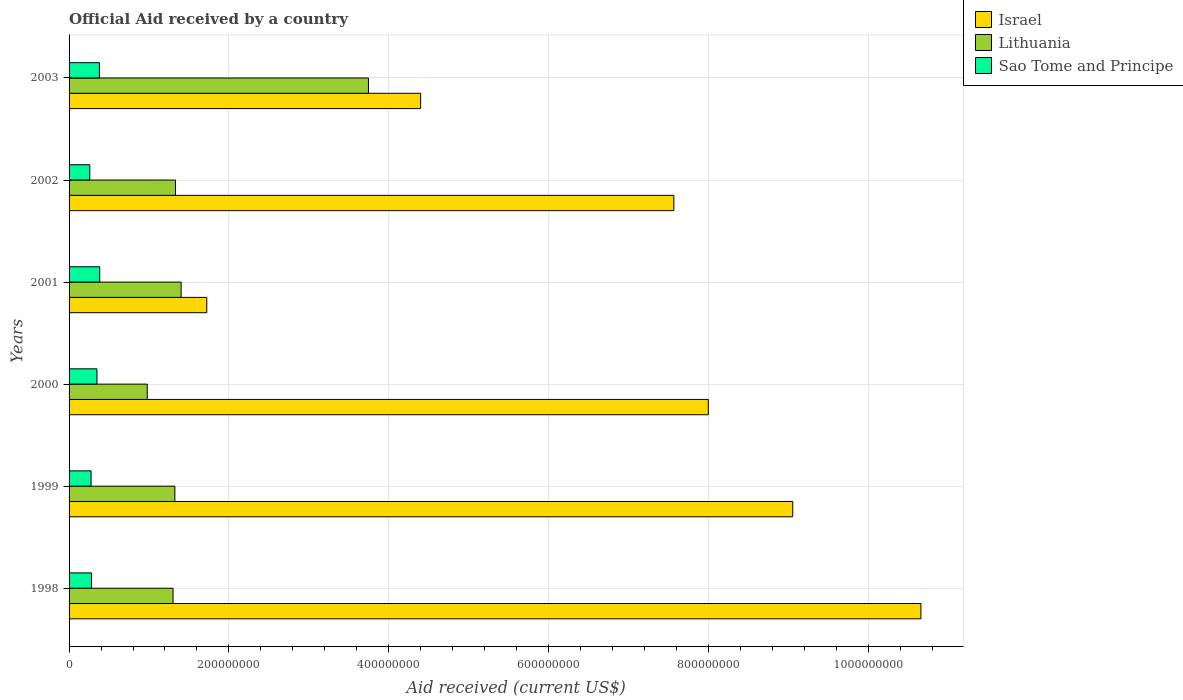How many bars are there on the 1st tick from the top?
Ensure brevity in your answer.  3. What is the net official aid received in Lithuania in 2002?
Your response must be concise. 1.33e+08. Across all years, what is the maximum net official aid received in Israel?
Your answer should be compact. 1.07e+09. Across all years, what is the minimum net official aid received in Sao Tome and Principe?
Ensure brevity in your answer.  2.59e+07. In which year was the net official aid received in Sao Tome and Principe maximum?
Provide a short and direct response. 2001. What is the total net official aid received in Israel in the graph?
Offer a terse response. 4.14e+09. What is the difference between the net official aid received in Lithuania in 1998 and that in 2002?
Offer a terse response. -3.08e+06. What is the difference between the net official aid received in Sao Tome and Principe in 2000 and the net official aid received in Israel in 2002?
Provide a succinct answer. -7.22e+08. What is the average net official aid received in Israel per year?
Ensure brevity in your answer.  6.90e+08. In the year 2000, what is the difference between the net official aid received in Lithuania and net official aid received in Israel?
Offer a terse response. -7.02e+08. In how many years, is the net official aid received in Israel greater than 360000000 US$?
Make the answer very short. 5. What is the ratio of the net official aid received in Sao Tome and Principe in 1998 to that in 2001?
Ensure brevity in your answer.  0.73. Is the net official aid received in Lithuania in 1999 less than that in 2001?
Provide a succinct answer. Yes. Is the difference between the net official aid received in Lithuania in 1999 and 2000 greater than the difference between the net official aid received in Israel in 1999 and 2000?
Offer a very short reply. No. What is the difference between the highest and the lowest net official aid received in Lithuania?
Your answer should be compact. 2.77e+08. In how many years, is the net official aid received in Lithuania greater than the average net official aid received in Lithuania taken over all years?
Provide a succinct answer. 1. What does the 2nd bar from the bottom in 2001 represents?
Keep it short and to the point. Lithuania. Is it the case that in every year, the sum of the net official aid received in Israel and net official aid received in Lithuania is greater than the net official aid received in Sao Tome and Principe?
Offer a very short reply. Yes. Are all the bars in the graph horizontal?
Offer a terse response. Yes. What is the difference between two consecutive major ticks on the X-axis?
Provide a succinct answer. 2.00e+08. Does the graph contain grids?
Your response must be concise. Yes. How many legend labels are there?
Give a very brief answer. 3. How are the legend labels stacked?
Provide a succinct answer. Vertical. What is the title of the graph?
Make the answer very short. Official Aid received by a country. What is the label or title of the X-axis?
Provide a short and direct response. Aid received (current US$). What is the Aid received (current US$) of Israel in 1998?
Ensure brevity in your answer.  1.07e+09. What is the Aid received (current US$) of Lithuania in 1998?
Offer a very short reply. 1.30e+08. What is the Aid received (current US$) in Sao Tome and Principe in 1998?
Give a very brief answer. 2.81e+07. What is the Aid received (current US$) of Israel in 1999?
Your response must be concise. 9.06e+08. What is the Aid received (current US$) of Lithuania in 1999?
Your response must be concise. 1.32e+08. What is the Aid received (current US$) of Sao Tome and Principe in 1999?
Ensure brevity in your answer.  2.75e+07. What is the Aid received (current US$) of Israel in 2000?
Offer a very short reply. 8.00e+08. What is the Aid received (current US$) of Lithuania in 2000?
Provide a succinct answer. 9.78e+07. What is the Aid received (current US$) in Sao Tome and Principe in 2000?
Offer a terse response. 3.49e+07. What is the Aid received (current US$) of Israel in 2001?
Provide a short and direct response. 1.72e+08. What is the Aid received (current US$) in Lithuania in 2001?
Your response must be concise. 1.40e+08. What is the Aid received (current US$) in Sao Tome and Principe in 2001?
Ensure brevity in your answer.  3.84e+07. What is the Aid received (current US$) of Israel in 2002?
Provide a succinct answer. 7.57e+08. What is the Aid received (current US$) of Lithuania in 2002?
Offer a terse response. 1.33e+08. What is the Aid received (current US$) in Sao Tome and Principe in 2002?
Ensure brevity in your answer.  2.59e+07. What is the Aid received (current US$) of Israel in 2003?
Provide a succinct answer. 4.40e+08. What is the Aid received (current US$) of Lithuania in 2003?
Provide a short and direct response. 3.75e+08. What is the Aid received (current US$) of Sao Tome and Principe in 2003?
Ensure brevity in your answer.  3.80e+07. Across all years, what is the maximum Aid received (current US$) of Israel?
Your answer should be very brief. 1.07e+09. Across all years, what is the maximum Aid received (current US$) in Lithuania?
Your answer should be very brief. 3.75e+08. Across all years, what is the maximum Aid received (current US$) of Sao Tome and Principe?
Ensure brevity in your answer.  3.84e+07. Across all years, what is the minimum Aid received (current US$) of Israel?
Provide a short and direct response. 1.72e+08. Across all years, what is the minimum Aid received (current US$) in Lithuania?
Ensure brevity in your answer.  9.78e+07. Across all years, what is the minimum Aid received (current US$) in Sao Tome and Principe?
Your response must be concise. 2.59e+07. What is the total Aid received (current US$) of Israel in the graph?
Provide a succinct answer. 4.14e+09. What is the total Aid received (current US$) in Lithuania in the graph?
Your answer should be very brief. 1.01e+09. What is the total Aid received (current US$) of Sao Tome and Principe in the graph?
Your answer should be very brief. 1.93e+08. What is the difference between the Aid received (current US$) of Israel in 1998 and that in 1999?
Provide a succinct answer. 1.60e+08. What is the difference between the Aid received (current US$) in Lithuania in 1998 and that in 1999?
Provide a short and direct response. -2.27e+06. What is the difference between the Aid received (current US$) of Sao Tome and Principe in 1998 and that in 1999?
Keep it short and to the point. 5.40e+05. What is the difference between the Aid received (current US$) of Israel in 1998 and that in 2000?
Offer a terse response. 2.66e+08. What is the difference between the Aid received (current US$) of Lithuania in 1998 and that in 2000?
Offer a very short reply. 3.23e+07. What is the difference between the Aid received (current US$) in Sao Tome and Principe in 1998 and that in 2000?
Provide a short and direct response. -6.83e+06. What is the difference between the Aid received (current US$) in Israel in 1998 and that in 2001?
Offer a terse response. 8.94e+08. What is the difference between the Aid received (current US$) in Lithuania in 1998 and that in 2001?
Your answer should be compact. -1.01e+07. What is the difference between the Aid received (current US$) of Sao Tome and Principe in 1998 and that in 2001?
Your answer should be compact. -1.03e+07. What is the difference between the Aid received (current US$) in Israel in 1998 and that in 2002?
Your response must be concise. 3.09e+08. What is the difference between the Aid received (current US$) of Lithuania in 1998 and that in 2002?
Offer a very short reply. -3.08e+06. What is the difference between the Aid received (current US$) of Sao Tome and Principe in 1998 and that in 2002?
Provide a succinct answer. 2.14e+06. What is the difference between the Aid received (current US$) of Israel in 1998 and that in 2003?
Your answer should be compact. 6.26e+08. What is the difference between the Aid received (current US$) of Lithuania in 1998 and that in 2003?
Your response must be concise. -2.45e+08. What is the difference between the Aid received (current US$) in Sao Tome and Principe in 1998 and that in 2003?
Keep it short and to the point. -9.92e+06. What is the difference between the Aid received (current US$) of Israel in 1999 and that in 2000?
Your answer should be compact. 1.06e+08. What is the difference between the Aid received (current US$) in Lithuania in 1999 and that in 2000?
Provide a succinct answer. 3.46e+07. What is the difference between the Aid received (current US$) in Sao Tome and Principe in 1999 and that in 2000?
Your answer should be compact. -7.37e+06. What is the difference between the Aid received (current US$) of Israel in 1999 and that in 2001?
Your response must be concise. 7.33e+08. What is the difference between the Aid received (current US$) of Lithuania in 1999 and that in 2001?
Your answer should be very brief. -7.83e+06. What is the difference between the Aid received (current US$) in Sao Tome and Principe in 1999 and that in 2001?
Provide a succinct answer. -1.08e+07. What is the difference between the Aid received (current US$) in Israel in 1999 and that in 2002?
Ensure brevity in your answer.  1.49e+08. What is the difference between the Aid received (current US$) in Lithuania in 1999 and that in 2002?
Your response must be concise. -8.10e+05. What is the difference between the Aid received (current US$) in Sao Tome and Principe in 1999 and that in 2002?
Offer a terse response. 1.60e+06. What is the difference between the Aid received (current US$) in Israel in 1999 and that in 2003?
Your answer should be very brief. 4.66e+08. What is the difference between the Aid received (current US$) of Lithuania in 1999 and that in 2003?
Your response must be concise. -2.42e+08. What is the difference between the Aid received (current US$) in Sao Tome and Principe in 1999 and that in 2003?
Ensure brevity in your answer.  -1.05e+07. What is the difference between the Aid received (current US$) in Israel in 2000 and that in 2001?
Provide a short and direct response. 6.28e+08. What is the difference between the Aid received (current US$) of Lithuania in 2000 and that in 2001?
Give a very brief answer. -4.24e+07. What is the difference between the Aid received (current US$) in Sao Tome and Principe in 2000 and that in 2001?
Give a very brief answer. -3.47e+06. What is the difference between the Aid received (current US$) in Israel in 2000 and that in 2002?
Ensure brevity in your answer.  4.31e+07. What is the difference between the Aid received (current US$) of Lithuania in 2000 and that in 2002?
Give a very brief answer. -3.54e+07. What is the difference between the Aid received (current US$) in Sao Tome and Principe in 2000 and that in 2002?
Keep it short and to the point. 8.97e+06. What is the difference between the Aid received (current US$) in Israel in 2000 and that in 2003?
Your response must be concise. 3.60e+08. What is the difference between the Aid received (current US$) in Lithuania in 2000 and that in 2003?
Your answer should be very brief. -2.77e+08. What is the difference between the Aid received (current US$) of Sao Tome and Principe in 2000 and that in 2003?
Keep it short and to the point. -3.09e+06. What is the difference between the Aid received (current US$) of Israel in 2001 and that in 2002?
Give a very brief answer. -5.85e+08. What is the difference between the Aid received (current US$) of Lithuania in 2001 and that in 2002?
Offer a terse response. 7.02e+06. What is the difference between the Aid received (current US$) of Sao Tome and Principe in 2001 and that in 2002?
Keep it short and to the point. 1.24e+07. What is the difference between the Aid received (current US$) of Israel in 2001 and that in 2003?
Give a very brief answer. -2.68e+08. What is the difference between the Aid received (current US$) in Lithuania in 2001 and that in 2003?
Give a very brief answer. -2.34e+08. What is the difference between the Aid received (current US$) of Sao Tome and Principe in 2001 and that in 2003?
Keep it short and to the point. 3.80e+05. What is the difference between the Aid received (current US$) of Israel in 2002 and that in 2003?
Your answer should be compact. 3.17e+08. What is the difference between the Aid received (current US$) of Lithuania in 2002 and that in 2003?
Provide a short and direct response. -2.41e+08. What is the difference between the Aid received (current US$) of Sao Tome and Principe in 2002 and that in 2003?
Offer a very short reply. -1.21e+07. What is the difference between the Aid received (current US$) of Israel in 1998 and the Aid received (current US$) of Lithuania in 1999?
Provide a short and direct response. 9.34e+08. What is the difference between the Aid received (current US$) of Israel in 1998 and the Aid received (current US$) of Sao Tome and Principe in 1999?
Your response must be concise. 1.04e+09. What is the difference between the Aid received (current US$) in Lithuania in 1998 and the Aid received (current US$) in Sao Tome and Principe in 1999?
Offer a terse response. 1.03e+08. What is the difference between the Aid received (current US$) in Israel in 1998 and the Aid received (current US$) in Lithuania in 2000?
Provide a succinct answer. 9.68e+08. What is the difference between the Aid received (current US$) of Israel in 1998 and the Aid received (current US$) of Sao Tome and Principe in 2000?
Keep it short and to the point. 1.03e+09. What is the difference between the Aid received (current US$) in Lithuania in 1998 and the Aid received (current US$) in Sao Tome and Principe in 2000?
Ensure brevity in your answer.  9.52e+07. What is the difference between the Aid received (current US$) in Israel in 1998 and the Aid received (current US$) in Lithuania in 2001?
Provide a short and direct response. 9.26e+08. What is the difference between the Aid received (current US$) in Israel in 1998 and the Aid received (current US$) in Sao Tome and Principe in 2001?
Keep it short and to the point. 1.03e+09. What is the difference between the Aid received (current US$) in Lithuania in 1998 and the Aid received (current US$) in Sao Tome and Principe in 2001?
Provide a short and direct response. 9.18e+07. What is the difference between the Aid received (current US$) of Israel in 1998 and the Aid received (current US$) of Lithuania in 2002?
Your answer should be compact. 9.33e+08. What is the difference between the Aid received (current US$) of Israel in 1998 and the Aid received (current US$) of Sao Tome and Principe in 2002?
Keep it short and to the point. 1.04e+09. What is the difference between the Aid received (current US$) of Lithuania in 1998 and the Aid received (current US$) of Sao Tome and Principe in 2002?
Your answer should be compact. 1.04e+08. What is the difference between the Aid received (current US$) in Israel in 1998 and the Aid received (current US$) in Lithuania in 2003?
Give a very brief answer. 6.91e+08. What is the difference between the Aid received (current US$) in Israel in 1998 and the Aid received (current US$) in Sao Tome and Principe in 2003?
Give a very brief answer. 1.03e+09. What is the difference between the Aid received (current US$) in Lithuania in 1998 and the Aid received (current US$) in Sao Tome and Principe in 2003?
Your answer should be very brief. 9.22e+07. What is the difference between the Aid received (current US$) of Israel in 1999 and the Aid received (current US$) of Lithuania in 2000?
Offer a terse response. 8.08e+08. What is the difference between the Aid received (current US$) in Israel in 1999 and the Aid received (current US$) in Sao Tome and Principe in 2000?
Your answer should be compact. 8.71e+08. What is the difference between the Aid received (current US$) of Lithuania in 1999 and the Aid received (current US$) of Sao Tome and Principe in 2000?
Keep it short and to the point. 9.75e+07. What is the difference between the Aid received (current US$) in Israel in 1999 and the Aid received (current US$) in Lithuania in 2001?
Offer a terse response. 7.65e+08. What is the difference between the Aid received (current US$) in Israel in 1999 and the Aid received (current US$) in Sao Tome and Principe in 2001?
Offer a very short reply. 8.67e+08. What is the difference between the Aid received (current US$) of Lithuania in 1999 and the Aid received (current US$) of Sao Tome and Principe in 2001?
Make the answer very short. 9.40e+07. What is the difference between the Aid received (current US$) in Israel in 1999 and the Aid received (current US$) in Lithuania in 2002?
Provide a short and direct response. 7.72e+08. What is the difference between the Aid received (current US$) of Israel in 1999 and the Aid received (current US$) of Sao Tome and Principe in 2002?
Offer a very short reply. 8.80e+08. What is the difference between the Aid received (current US$) of Lithuania in 1999 and the Aid received (current US$) of Sao Tome and Principe in 2002?
Ensure brevity in your answer.  1.06e+08. What is the difference between the Aid received (current US$) in Israel in 1999 and the Aid received (current US$) in Lithuania in 2003?
Provide a succinct answer. 5.31e+08. What is the difference between the Aid received (current US$) in Israel in 1999 and the Aid received (current US$) in Sao Tome and Principe in 2003?
Your answer should be compact. 8.68e+08. What is the difference between the Aid received (current US$) in Lithuania in 1999 and the Aid received (current US$) in Sao Tome and Principe in 2003?
Offer a very short reply. 9.44e+07. What is the difference between the Aid received (current US$) of Israel in 2000 and the Aid received (current US$) of Lithuania in 2001?
Make the answer very short. 6.60e+08. What is the difference between the Aid received (current US$) in Israel in 2000 and the Aid received (current US$) in Sao Tome and Principe in 2001?
Make the answer very short. 7.62e+08. What is the difference between the Aid received (current US$) in Lithuania in 2000 and the Aid received (current US$) in Sao Tome and Principe in 2001?
Offer a very short reply. 5.95e+07. What is the difference between the Aid received (current US$) in Israel in 2000 and the Aid received (current US$) in Lithuania in 2002?
Provide a short and direct response. 6.67e+08. What is the difference between the Aid received (current US$) in Israel in 2000 and the Aid received (current US$) in Sao Tome and Principe in 2002?
Your answer should be very brief. 7.74e+08. What is the difference between the Aid received (current US$) in Lithuania in 2000 and the Aid received (current US$) in Sao Tome and Principe in 2002?
Your response must be concise. 7.19e+07. What is the difference between the Aid received (current US$) of Israel in 2000 and the Aid received (current US$) of Lithuania in 2003?
Your answer should be compact. 4.25e+08. What is the difference between the Aid received (current US$) in Israel in 2000 and the Aid received (current US$) in Sao Tome and Principe in 2003?
Offer a terse response. 7.62e+08. What is the difference between the Aid received (current US$) in Lithuania in 2000 and the Aid received (current US$) in Sao Tome and Principe in 2003?
Keep it short and to the point. 5.98e+07. What is the difference between the Aid received (current US$) in Israel in 2001 and the Aid received (current US$) in Lithuania in 2002?
Keep it short and to the point. 3.91e+07. What is the difference between the Aid received (current US$) in Israel in 2001 and the Aid received (current US$) in Sao Tome and Principe in 2002?
Your response must be concise. 1.46e+08. What is the difference between the Aid received (current US$) in Lithuania in 2001 and the Aid received (current US$) in Sao Tome and Principe in 2002?
Your response must be concise. 1.14e+08. What is the difference between the Aid received (current US$) of Israel in 2001 and the Aid received (current US$) of Lithuania in 2003?
Make the answer very short. -2.02e+08. What is the difference between the Aid received (current US$) in Israel in 2001 and the Aid received (current US$) in Sao Tome and Principe in 2003?
Provide a succinct answer. 1.34e+08. What is the difference between the Aid received (current US$) in Lithuania in 2001 and the Aid received (current US$) in Sao Tome and Principe in 2003?
Your answer should be very brief. 1.02e+08. What is the difference between the Aid received (current US$) in Israel in 2002 and the Aid received (current US$) in Lithuania in 2003?
Keep it short and to the point. 3.82e+08. What is the difference between the Aid received (current US$) of Israel in 2002 and the Aid received (current US$) of Sao Tome and Principe in 2003?
Your response must be concise. 7.19e+08. What is the difference between the Aid received (current US$) in Lithuania in 2002 and the Aid received (current US$) in Sao Tome and Principe in 2003?
Make the answer very short. 9.52e+07. What is the average Aid received (current US$) in Israel per year?
Provide a succinct answer. 6.90e+08. What is the average Aid received (current US$) of Lithuania per year?
Provide a succinct answer. 1.68e+08. What is the average Aid received (current US$) of Sao Tome and Principe per year?
Ensure brevity in your answer.  3.21e+07. In the year 1998, what is the difference between the Aid received (current US$) in Israel and Aid received (current US$) in Lithuania?
Ensure brevity in your answer.  9.36e+08. In the year 1998, what is the difference between the Aid received (current US$) in Israel and Aid received (current US$) in Sao Tome and Principe?
Provide a short and direct response. 1.04e+09. In the year 1998, what is the difference between the Aid received (current US$) of Lithuania and Aid received (current US$) of Sao Tome and Principe?
Provide a short and direct response. 1.02e+08. In the year 1999, what is the difference between the Aid received (current US$) of Israel and Aid received (current US$) of Lithuania?
Ensure brevity in your answer.  7.73e+08. In the year 1999, what is the difference between the Aid received (current US$) in Israel and Aid received (current US$) in Sao Tome and Principe?
Provide a short and direct response. 8.78e+08. In the year 1999, what is the difference between the Aid received (current US$) of Lithuania and Aid received (current US$) of Sao Tome and Principe?
Offer a terse response. 1.05e+08. In the year 2000, what is the difference between the Aid received (current US$) of Israel and Aid received (current US$) of Lithuania?
Ensure brevity in your answer.  7.02e+08. In the year 2000, what is the difference between the Aid received (current US$) of Israel and Aid received (current US$) of Sao Tome and Principe?
Provide a succinct answer. 7.65e+08. In the year 2000, what is the difference between the Aid received (current US$) of Lithuania and Aid received (current US$) of Sao Tome and Principe?
Your response must be concise. 6.29e+07. In the year 2001, what is the difference between the Aid received (current US$) in Israel and Aid received (current US$) in Lithuania?
Ensure brevity in your answer.  3.21e+07. In the year 2001, what is the difference between the Aid received (current US$) of Israel and Aid received (current US$) of Sao Tome and Principe?
Give a very brief answer. 1.34e+08. In the year 2001, what is the difference between the Aid received (current US$) of Lithuania and Aid received (current US$) of Sao Tome and Principe?
Ensure brevity in your answer.  1.02e+08. In the year 2002, what is the difference between the Aid received (current US$) of Israel and Aid received (current US$) of Lithuania?
Offer a terse response. 6.24e+08. In the year 2002, what is the difference between the Aid received (current US$) of Israel and Aid received (current US$) of Sao Tome and Principe?
Your response must be concise. 7.31e+08. In the year 2002, what is the difference between the Aid received (current US$) of Lithuania and Aid received (current US$) of Sao Tome and Principe?
Provide a succinct answer. 1.07e+08. In the year 2003, what is the difference between the Aid received (current US$) in Israel and Aid received (current US$) in Lithuania?
Give a very brief answer. 6.53e+07. In the year 2003, what is the difference between the Aid received (current US$) in Israel and Aid received (current US$) in Sao Tome and Principe?
Offer a terse response. 4.02e+08. In the year 2003, what is the difference between the Aid received (current US$) of Lithuania and Aid received (current US$) of Sao Tome and Principe?
Your answer should be very brief. 3.37e+08. What is the ratio of the Aid received (current US$) of Israel in 1998 to that in 1999?
Your answer should be very brief. 1.18. What is the ratio of the Aid received (current US$) of Lithuania in 1998 to that in 1999?
Make the answer very short. 0.98. What is the ratio of the Aid received (current US$) in Sao Tome and Principe in 1998 to that in 1999?
Ensure brevity in your answer.  1.02. What is the ratio of the Aid received (current US$) in Israel in 1998 to that in 2000?
Give a very brief answer. 1.33. What is the ratio of the Aid received (current US$) of Lithuania in 1998 to that in 2000?
Your answer should be very brief. 1.33. What is the ratio of the Aid received (current US$) in Sao Tome and Principe in 1998 to that in 2000?
Offer a terse response. 0.8. What is the ratio of the Aid received (current US$) of Israel in 1998 to that in 2001?
Give a very brief answer. 6.19. What is the ratio of the Aid received (current US$) in Lithuania in 1998 to that in 2001?
Provide a succinct answer. 0.93. What is the ratio of the Aid received (current US$) in Sao Tome and Principe in 1998 to that in 2001?
Offer a very short reply. 0.73. What is the ratio of the Aid received (current US$) in Israel in 1998 to that in 2002?
Provide a short and direct response. 1.41. What is the ratio of the Aid received (current US$) in Lithuania in 1998 to that in 2002?
Make the answer very short. 0.98. What is the ratio of the Aid received (current US$) of Sao Tome and Principe in 1998 to that in 2002?
Give a very brief answer. 1.08. What is the ratio of the Aid received (current US$) of Israel in 1998 to that in 2003?
Give a very brief answer. 2.42. What is the ratio of the Aid received (current US$) of Lithuania in 1998 to that in 2003?
Provide a short and direct response. 0.35. What is the ratio of the Aid received (current US$) of Sao Tome and Principe in 1998 to that in 2003?
Keep it short and to the point. 0.74. What is the ratio of the Aid received (current US$) in Israel in 1999 to that in 2000?
Offer a very short reply. 1.13. What is the ratio of the Aid received (current US$) of Lithuania in 1999 to that in 2000?
Offer a very short reply. 1.35. What is the ratio of the Aid received (current US$) in Sao Tome and Principe in 1999 to that in 2000?
Keep it short and to the point. 0.79. What is the ratio of the Aid received (current US$) of Israel in 1999 to that in 2001?
Provide a succinct answer. 5.26. What is the ratio of the Aid received (current US$) of Lithuania in 1999 to that in 2001?
Your answer should be compact. 0.94. What is the ratio of the Aid received (current US$) in Sao Tome and Principe in 1999 to that in 2001?
Offer a terse response. 0.72. What is the ratio of the Aid received (current US$) in Israel in 1999 to that in 2002?
Ensure brevity in your answer.  1.2. What is the ratio of the Aid received (current US$) in Sao Tome and Principe in 1999 to that in 2002?
Provide a short and direct response. 1.06. What is the ratio of the Aid received (current US$) in Israel in 1999 to that in 2003?
Make the answer very short. 2.06. What is the ratio of the Aid received (current US$) of Lithuania in 1999 to that in 2003?
Your answer should be very brief. 0.35. What is the ratio of the Aid received (current US$) of Sao Tome and Principe in 1999 to that in 2003?
Offer a very short reply. 0.72. What is the ratio of the Aid received (current US$) in Israel in 2000 to that in 2001?
Offer a terse response. 4.64. What is the ratio of the Aid received (current US$) in Lithuania in 2000 to that in 2001?
Your answer should be compact. 0.7. What is the ratio of the Aid received (current US$) in Sao Tome and Principe in 2000 to that in 2001?
Your answer should be compact. 0.91. What is the ratio of the Aid received (current US$) in Israel in 2000 to that in 2002?
Provide a short and direct response. 1.06. What is the ratio of the Aid received (current US$) of Lithuania in 2000 to that in 2002?
Your answer should be very brief. 0.73. What is the ratio of the Aid received (current US$) in Sao Tome and Principe in 2000 to that in 2002?
Your answer should be very brief. 1.35. What is the ratio of the Aid received (current US$) in Israel in 2000 to that in 2003?
Your answer should be very brief. 1.82. What is the ratio of the Aid received (current US$) in Lithuania in 2000 to that in 2003?
Provide a short and direct response. 0.26. What is the ratio of the Aid received (current US$) in Sao Tome and Principe in 2000 to that in 2003?
Your response must be concise. 0.92. What is the ratio of the Aid received (current US$) of Israel in 2001 to that in 2002?
Provide a succinct answer. 0.23. What is the ratio of the Aid received (current US$) in Lithuania in 2001 to that in 2002?
Ensure brevity in your answer.  1.05. What is the ratio of the Aid received (current US$) of Sao Tome and Principe in 2001 to that in 2002?
Offer a very short reply. 1.48. What is the ratio of the Aid received (current US$) in Israel in 2001 to that in 2003?
Give a very brief answer. 0.39. What is the ratio of the Aid received (current US$) of Lithuania in 2001 to that in 2003?
Keep it short and to the point. 0.37. What is the ratio of the Aid received (current US$) in Sao Tome and Principe in 2001 to that in 2003?
Provide a short and direct response. 1.01. What is the ratio of the Aid received (current US$) of Israel in 2002 to that in 2003?
Your answer should be very brief. 1.72. What is the ratio of the Aid received (current US$) in Lithuania in 2002 to that in 2003?
Your answer should be very brief. 0.36. What is the ratio of the Aid received (current US$) in Sao Tome and Principe in 2002 to that in 2003?
Provide a succinct answer. 0.68. What is the difference between the highest and the second highest Aid received (current US$) of Israel?
Make the answer very short. 1.60e+08. What is the difference between the highest and the second highest Aid received (current US$) of Lithuania?
Offer a terse response. 2.34e+08. What is the difference between the highest and the second highest Aid received (current US$) of Sao Tome and Principe?
Make the answer very short. 3.80e+05. What is the difference between the highest and the lowest Aid received (current US$) of Israel?
Your answer should be very brief. 8.94e+08. What is the difference between the highest and the lowest Aid received (current US$) of Lithuania?
Make the answer very short. 2.77e+08. What is the difference between the highest and the lowest Aid received (current US$) in Sao Tome and Principe?
Offer a very short reply. 1.24e+07. 